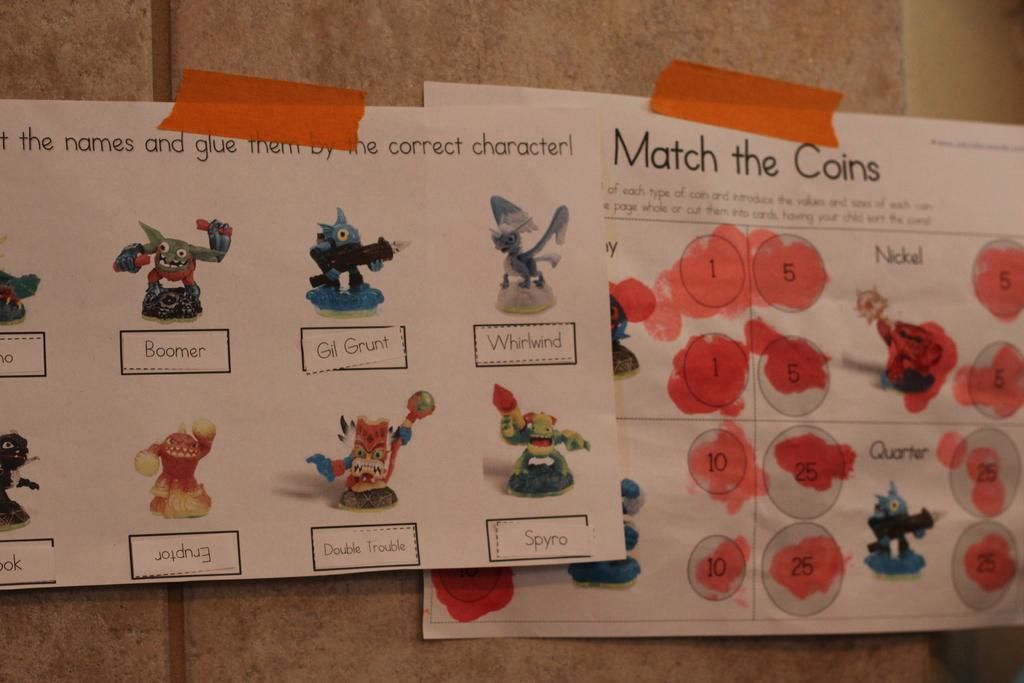What is present on the wall in the image? There are papers with toy pictures on the wall. Is there any other paper with a different type of content on the wall? Yes, there is a paper with a painting and information on it. How does the number of toys increase in the image? There is no indication of an increase in the number of toys in the image; it only shows papers with toy pictures on the wall. 